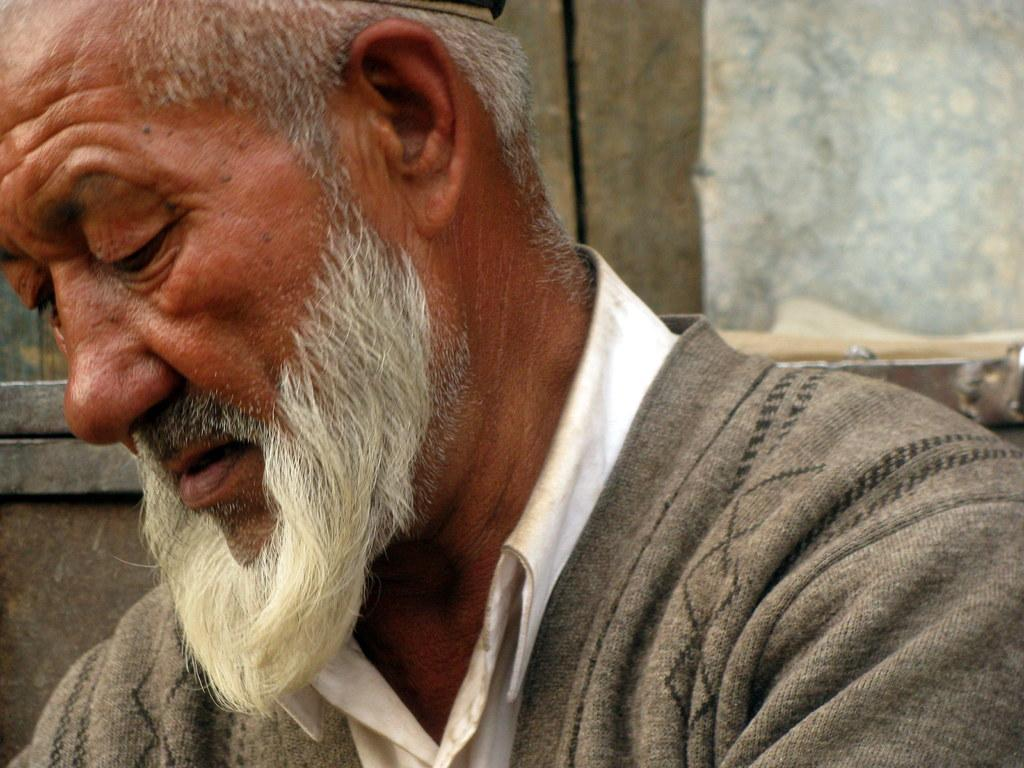What is the main subject of the image? There is a person in the image. What is the person wearing? The person is wearing a gray jacket. What is the person doing in the image? The person is sitting. What can be seen in the background of the image? There is a wall in the background of the image. What type of condition does the cactus have in the image? There is no cactus present in the image. What channel is the person watching on the television in the image? There is no television present in the image. 